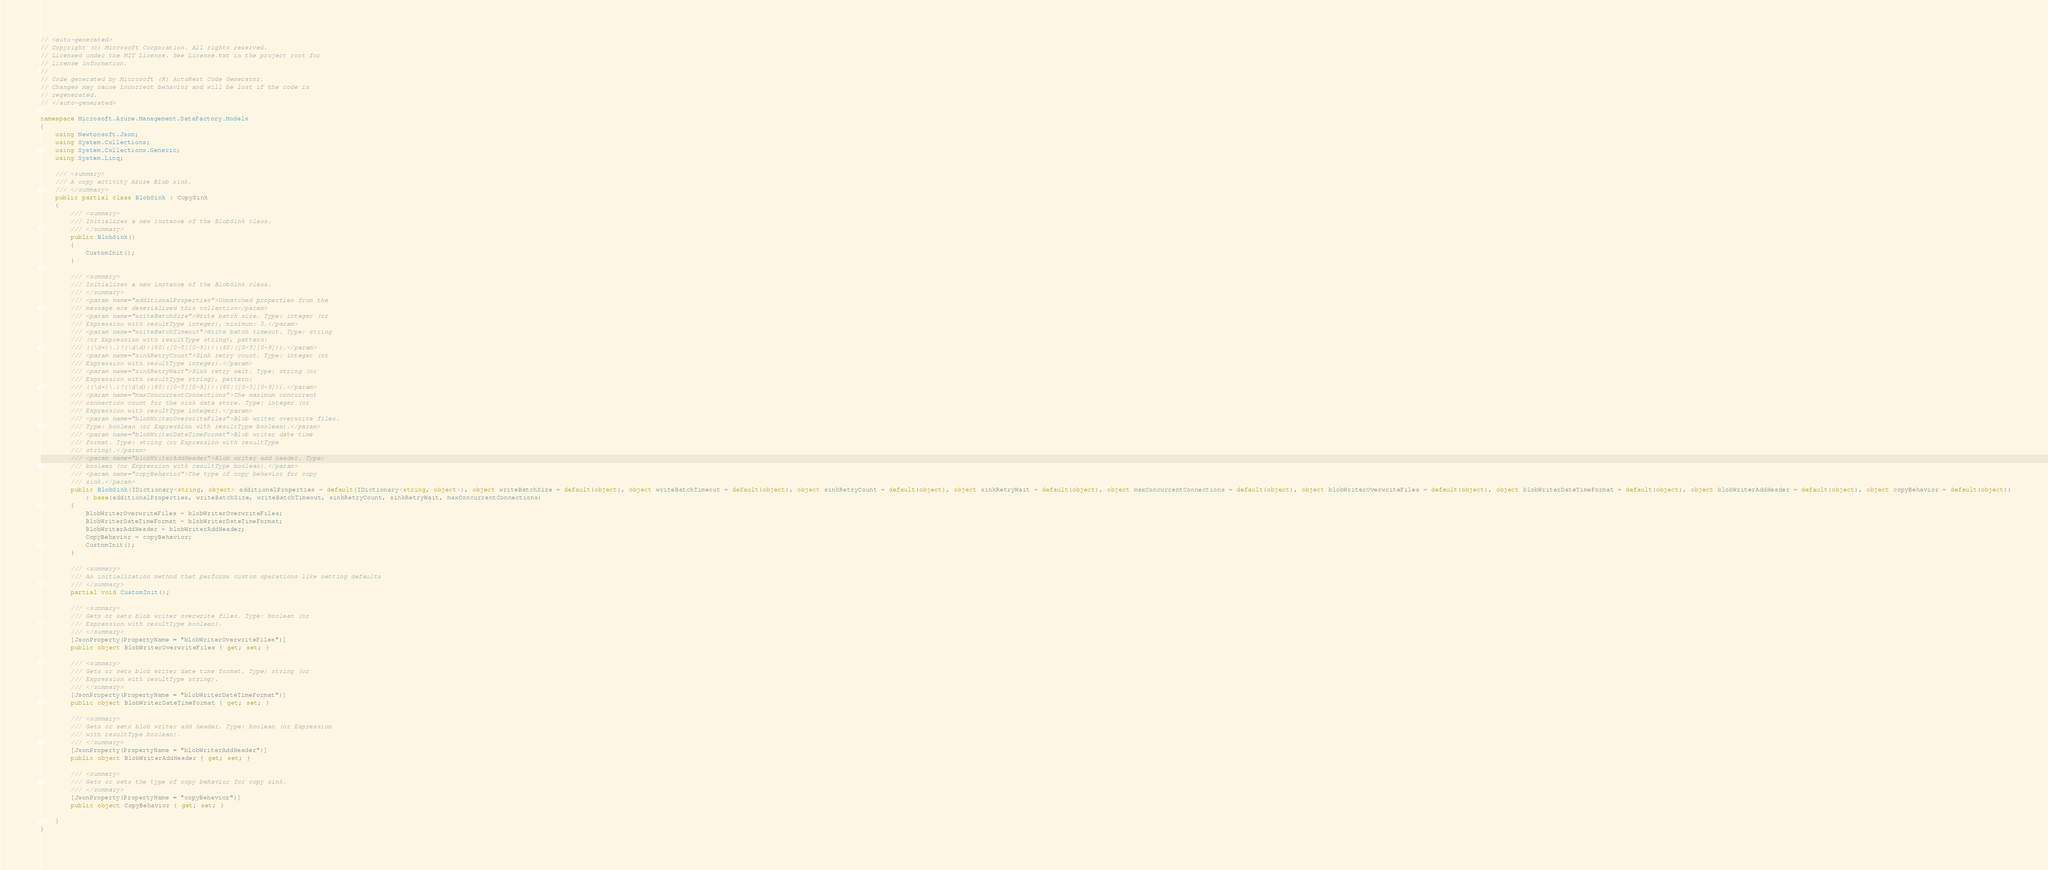Convert code to text. <code><loc_0><loc_0><loc_500><loc_500><_C#_>// <auto-generated>
// Copyright (c) Microsoft Corporation. All rights reserved.
// Licensed under the MIT License. See License.txt in the project root for
// license information.
//
// Code generated by Microsoft (R) AutoRest Code Generator.
// Changes may cause incorrect behavior and will be lost if the code is
// regenerated.
// </auto-generated>

namespace Microsoft.Azure.Management.DataFactory.Models
{
    using Newtonsoft.Json;
    using System.Collections;
    using System.Collections.Generic;
    using System.Linq;

    /// <summary>
    /// A copy activity Azure Blob sink.
    /// </summary>
    public partial class BlobSink : CopySink
    {
        /// <summary>
        /// Initializes a new instance of the BlobSink class.
        /// </summary>
        public BlobSink()
        {
            CustomInit();
        }

        /// <summary>
        /// Initializes a new instance of the BlobSink class.
        /// </summary>
        /// <param name="additionalProperties">Unmatched properties from the
        /// message are deserialized this collection</param>
        /// <param name="writeBatchSize">Write batch size. Type: integer (or
        /// Expression with resultType integer), minimum: 0.</param>
        /// <param name="writeBatchTimeout">Write batch timeout. Type: string
        /// (or Expression with resultType string), pattern:
        /// ((\d+)\.)?(\d\d):(60|([0-5][0-9])):(60|([0-5][0-9])).</param>
        /// <param name="sinkRetryCount">Sink retry count. Type: integer (or
        /// Expression with resultType integer).</param>
        /// <param name="sinkRetryWait">Sink retry wait. Type: string (or
        /// Expression with resultType string), pattern:
        /// ((\d+)\.)?(\d\d):(60|([0-5][0-9])):(60|([0-5][0-9])).</param>
        /// <param name="maxConcurrentConnections">The maximum concurrent
        /// connection count for the sink data store. Type: integer (or
        /// Expression with resultType integer).</param>
        /// <param name="blobWriterOverwriteFiles">Blob writer overwrite files.
        /// Type: boolean (or Expression with resultType boolean).</param>
        /// <param name="blobWriterDateTimeFormat">Blob writer date time
        /// format. Type: string (or Expression with resultType
        /// string).</param>
        /// <param name="blobWriterAddHeader">Blob writer add header. Type:
        /// boolean (or Expression with resultType boolean).</param>
        /// <param name="copyBehavior">The type of copy behavior for copy
        /// sink.</param>
        public BlobSink(IDictionary<string, object> additionalProperties = default(IDictionary<string, object>), object writeBatchSize = default(object), object writeBatchTimeout = default(object), object sinkRetryCount = default(object), object sinkRetryWait = default(object), object maxConcurrentConnections = default(object), object blobWriterOverwriteFiles = default(object), object blobWriterDateTimeFormat = default(object), object blobWriterAddHeader = default(object), object copyBehavior = default(object))
            : base(additionalProperties, writeBatchSize, writeBatchTimeout, sinkRetryCount, sinkRetryWait, maxConcurrentConnections)
        {
            BlobWriterOverwriteFiles = blobWriterOverwriteFiles;
            BlobWriterDateTimeFormat = blobWriterDateTimeFormat;
            BlobWriterAddHeader = blobWriterAddHeader;
            CopyBehavior = copyBehavior;
            CustomInit();
        }

        /// <summary>
        /// An initialization method that performs custom operations like setting defaults
        /// </summary>
        partial void CustomInit();

        /// <summary>
        /// Gets or sets blob writer overwrite files. Type: boolean (or
        /// Expression with resultType boolean).
        /// </summary>
        [JsonProperty(PropertyName = "blobWriterOverwriteFiles")]
        public object BlobWriterOverwriteFiles { get; set; }

        /// <summary>
        /// Gets or sets blob writer date time format. Type: string (or
        /// Expression with resultType string).
        /// </summary>
        [JsonProperty(PropertyName = "blobWriterDateTimeFormat")]
        public object BlobWriterDateTimeFormat { get; set; }

        /// <summary>
        /// Gets or sets blob writer add header. Type: boolean (or Expression
        /// with resultType boolean).
        /// </summary>
        [JsonProperty(PropertyName = "blobWriterAddHeader")]
        public object BlobWriterAddHeader { get; set; }

        /// <summary>
        /// Gets or sets the type of copy behavior for copy sink.
        /// </summary>
        [JsonProperty(PropertyName = "copyBehavior")]
        public object CopyBehavior { get; set; }

    }
}
</code> 